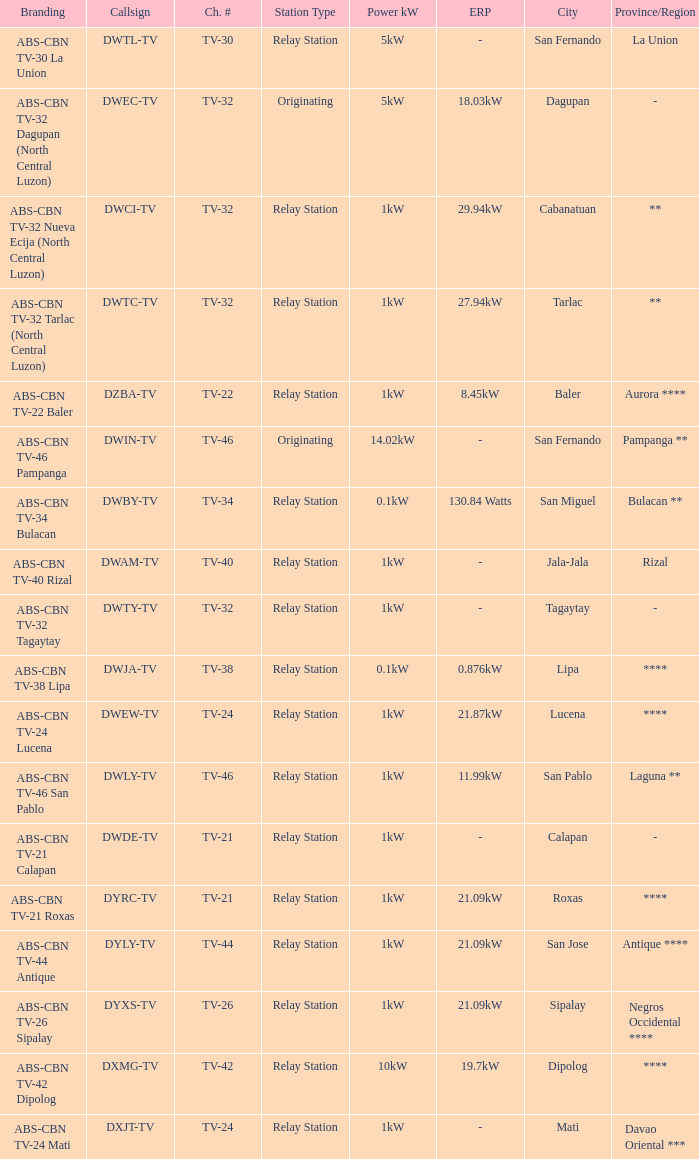The callsign DWEC-TV has what branding?  ABS-CBN TV-32 Dagupan (North Central Luzon). 